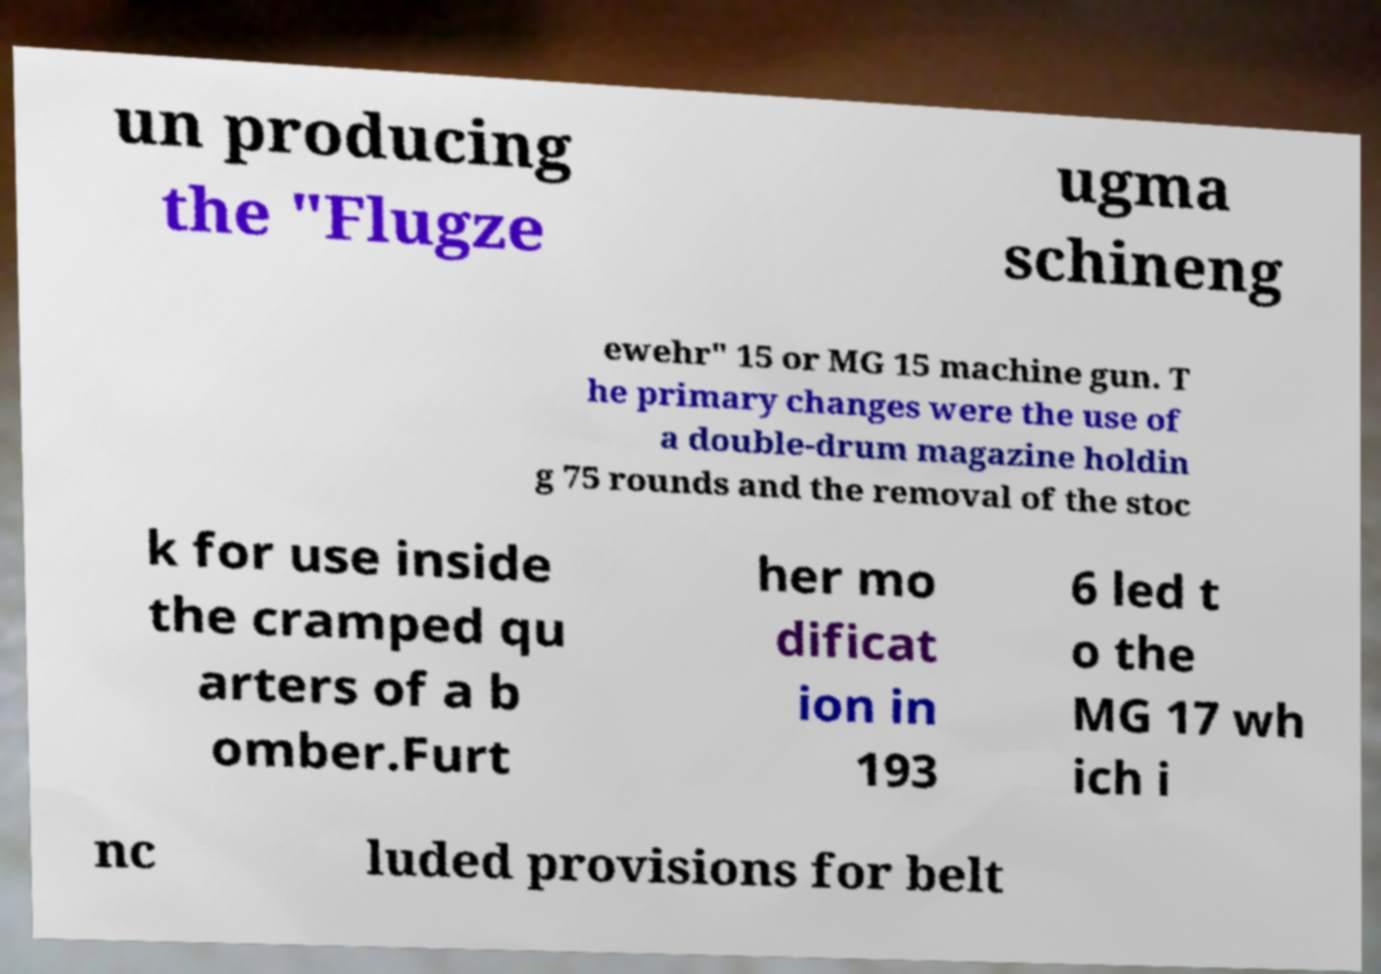There's text embedded in this image that I need extracted. Can you transcribe it verbatim? un producing the "Flugze ugma schineng ewehr" 15 or MG 15 machine gun. T he primary changes were the use of a double-drum magazine holdin g 75 rounds and the removal of the stoc k for use inside the cramped qu arters of a b omber.Furt her mo dificat ion in 193 6 led t o the MG 17 wh ich i nc luded provisions for belt 